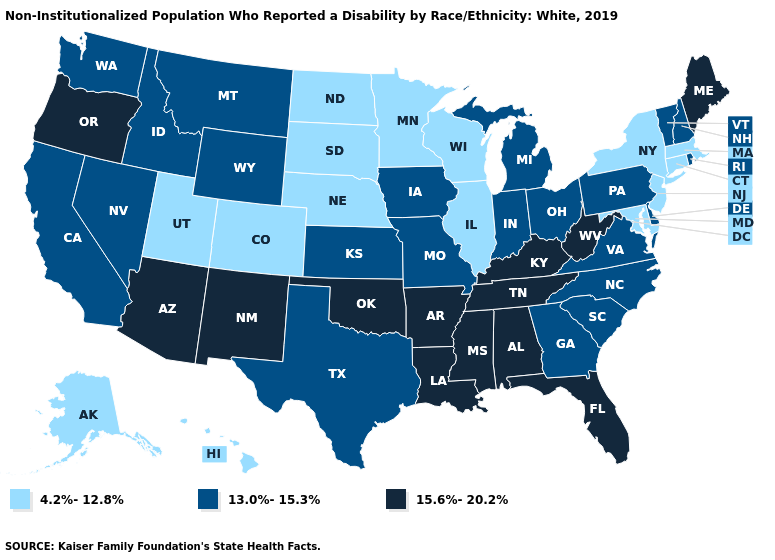Name the states that have a value in the range 15.6%-20.2%?
Give a very brief answer. Alabama, Arizona, Arkansas, Florida, Kentucky, Louisiana, Maine, Mississippi, New Mexico, Oklahoma, Oregon, Tennessee, West Virginia. Which states hav the highest value in the South?
Concise answer only. Alabama, Arkansas, Florida, Kentucky, Louisiana, Mississippi, Oklahoma, Tennessee, West Virginia. What is the highest value in the West ?
Short answer required. 15.6%-20.2%. Does New Mexico have the highest value in the USA?
Quick response, please. Yes. Which states hav the highest value in the MidWest?
Concise answer only. Indiana, Iowa, Kansas, Michigan, Missouri, Ohio. Does the map have missing data?
Keep it brief. No. What is the lowest value in states that border Wyoming?
Short answer required. 4.2%-12.8%. Name the states that have a value in the range 15.6%-20.2%?
Keep it brief. Alabama, Arizona, Arkansas, Florida, Kentucky, Louisiana, Maine, Mississippi, New Mexico, Oklahoma, Oregon, Tennessee, West Virginia. What is the lowest value in the West?
Be succinct. 4.2%-12.8%. How many symbols are there in the legend?
Quick response, please. 3. Does Connecticut have the same value as Minnesota?
Give a very brief answer. Yes. Name the states that have a value in the range 4.2%-12.8%?
Write a very short answer. Alaska, Colorado, Connecticut, Hawaii, Illinois, Maryland, Massachusetts, Minnesota, Nebraska, New Jersey, New York, North Dakota, South Dakota, Utah, Wisconsin. What is the value of Vermont?
Write a very short answer. 13.0%-15.3%. Name the states that have a value in the range 4.2%-12.8%?
Concise answer only. Alaska, Colorado, Connecticut, Hawaii, Illinois, Maryland, Massachusetts, Minnesota, Nebraska, New Jersey, New York, North Dakota, South Dakota, Utah, Wisconsin. Among the states that border Maryland , which have the lowest value?
Be succinct. Delaware, Pennsylvania, Virginia. 